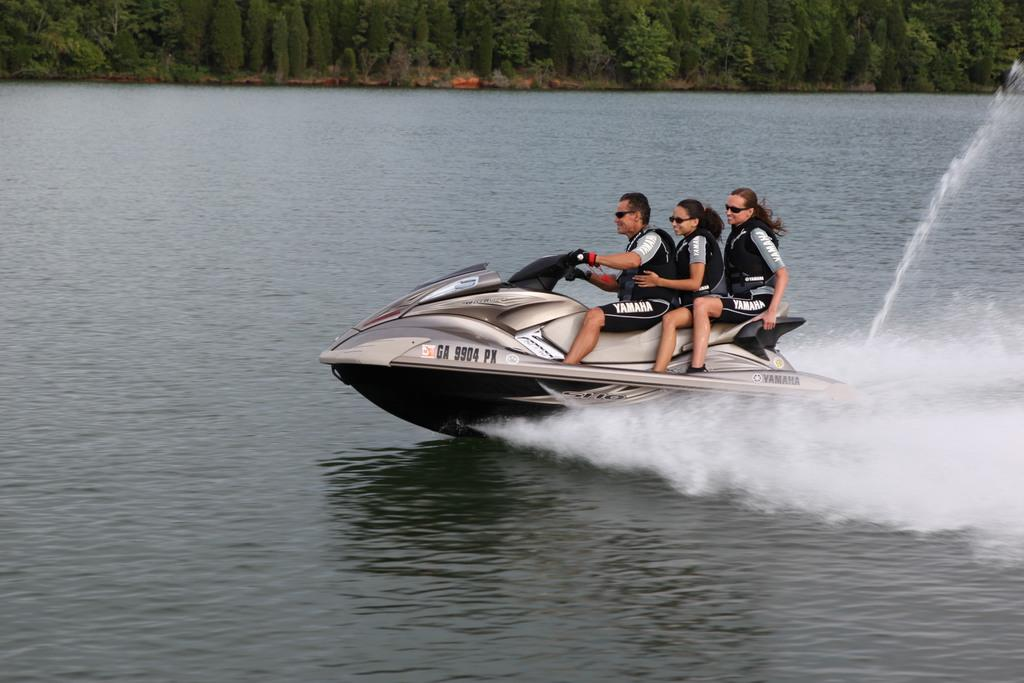What is the main subject of the image? The main subject of the image is a person driving a speed boat. Are there any other people in the speed boat? Yes, there are two people sitting behind the driver in the speed boat. What can be seen in the background of the image? There are trees in the background of the image. What type of insect is sitting on the top of the speed boat in the image? There is no insect visible on the speed boat in the image. How many girls are present in the image? The image does not show any girls; it only features people driving and sitting in a speed boat. 